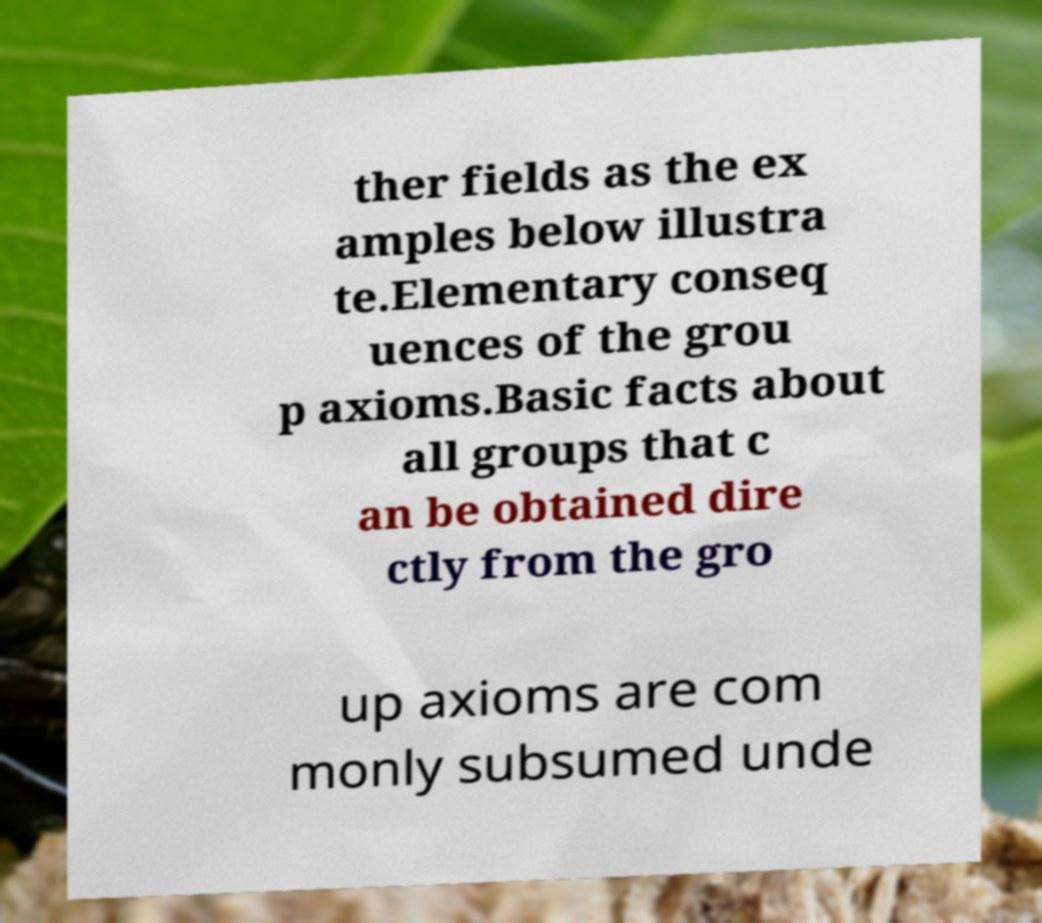There's text embedded in this image that I need extracted. Can you transcribe it verbatim? ther fields as the ex amples below illustra te.Elementary conseq uences of the grou p axioms.Basic facts about all groups that c an be obtained dire ctly from the gro up axioms are com monly subsumed unde 